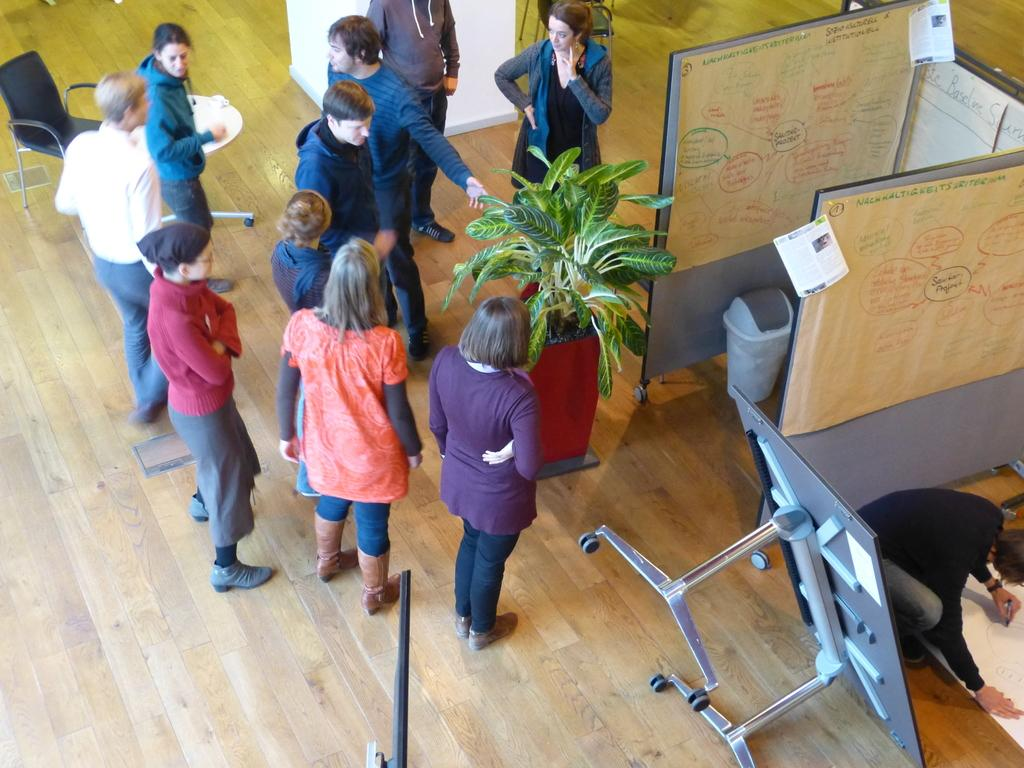What are the people in the image doing? There are people standing in the image, and one person is sitting on the floor. What objects are present in the image? There are chairs, a potted plant, and boards in the image. What is the person sitting on the floor doing? The person sitting on the floor is drawing on a chart. What hobbies do the father and sisters have in the image? There is no mention of a father or sisters in the image, so we cannot determine their hobbies. 